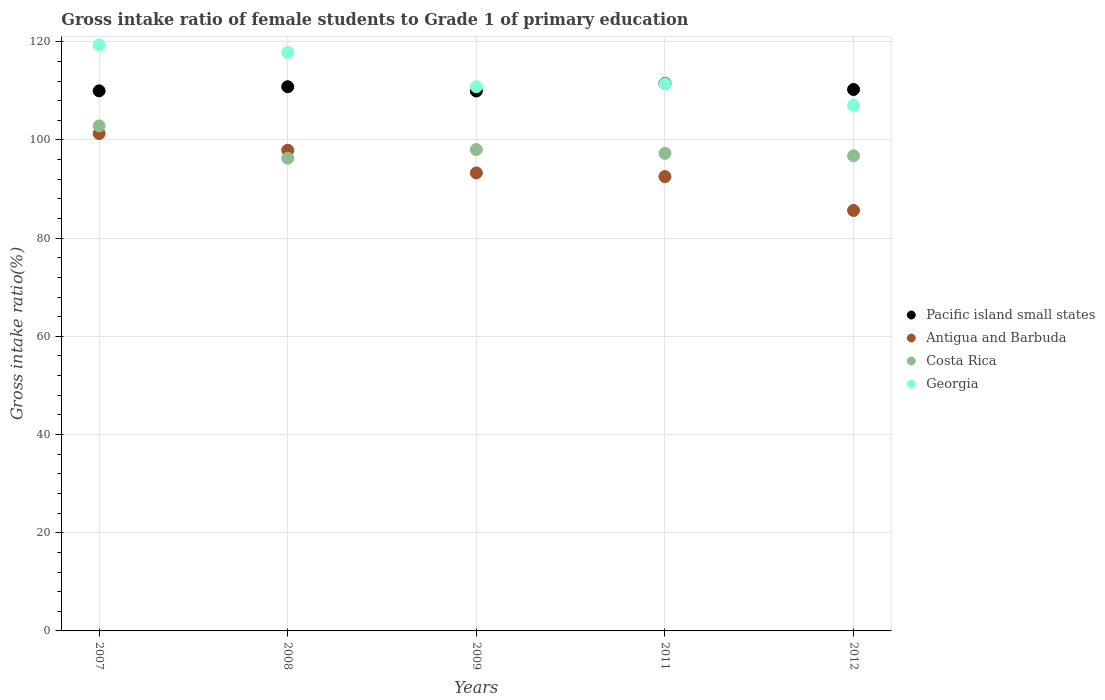How many different coloured dotlines are there?
Offer a terse response. 4. What is the gross intake ratio in Pacific island small states in 2007?
Keep it short and to the point. 110. Across all years, what is the maximum gross intake ratio in Costa Rica?
Ensure brevity in your answer.  102.86. Across all years, what is the minimum gross intake ratio in Georgia?
Provide a succinct answer. 107.07. In which year was the gross intake ratio in Antigua and Barbuda maximum?
Your response must be concise. 2007. In which year was the gross intake ratio in Antigua and Barbuda minimum?
Provide a succinct answer. 2012. What is the total gross intake ratio in Costa Rica in the graph?
Provide a short and direct response. 491.23. What is the difference between the gross intake ratio in Pacific island small states in 2009 and that in 2011?
Make the answer very short. -1.52. What is the difference between the gross intake ratio in Costa Rica in 2011 and the gross intake ratio in Pacific island small states in 2012?
Offer a terse response. -13.01. What is the average gross intake ratio in Costa Rica per year?
Keep it short and to the point. 98.25. In the year 2009, what is the difference between the gross intake ratio in Pacific island small states and gross intake ratio in Antigua and Barbuda?
Ensure brevity in your answer.  16.69. In how many years, is the gross intake ratio in Pacific island small states greater than 60 %?
Give a very brief answer. 5. What is the ratio of the gross intake ratio in Antigua and Barbuda in 2007 to that in 2011?
Make the answer very short. 1.09. What is the difference between the highest and the second highest gross intake ratio in Costa Rica?
Ensure brevity in your answer.  4.82. What is the difference between the highest and the lowest gross intake ratio in Antigua and Barbuda?
Your answer should be very brief. 15.67. Is the sum of the gross intake ratio in Pacific island small states in 2007 and 2011 greater than the maximum gross intake ratio in Antigua and Barbuda across all years?
Offer a very short reply. Yes. Is it the case that in every year, the sum of the gross intake ratio in Pacific island small states and gross intake ratio in Antigua and Barbuda  is greater than the gross intake ratio in Costa Rica?
Make the answer very short. Yes. Does the gross intake ratio in Georgia monotonically increase over the years?
Provide a short and direct response. No. Is the gross intake ratio in Georgia strictly less than the gross intake ratio in Antigua and Barbuda over the years?
Your response must be concise. No. How many years are there in the graph?
Your answer should be very brief. 5. What is the difference between two consecutive major ticks on the Y-axis?
Provide a short and direct response. 20. How are the legend labels stacked?
Offer a very short reply. Vertical. What is the title of the graph?
Offer a very short reply. Gross intake ratio of female students to Grade 1 of primary education. Does "Latin America(developing only)" appear as one of the legend labels in the graph?
Your response must be concise. No. What is the label or title of the Y-axis?
Keep it short and to the point. Gross intake ratio(%). What is the Gross intake ratio(%) in Pacific island small states in 2007?
Keep it short and to the point. 110. What is the Gross intake ratio(%) in Antigua and Barbuda in 2007?
Your answer should be compact. 101.31. What is the Gross intake ratio(%) of Costa Rica in 2007?
Offer a terse response. 102.86. What is the Gross intake ratio(%) of Georgia in 2007?
Your answer should be very brief. 119.37. What is the Gross intake ratio(%) in Pacific island small states in 2008?
Keep it short and to the point. 110.84. What is the Gross intake ratio(%) of Antigua and Barbuda in 2008?
Offer a very short reply. 97.9. What is the Gross intake ratio(%) of Costa Rica in 2008?
Your answer should be very brief. 96.28. What is the Gross intake ratio(%) of Georgia in 2008?
Keep it short and to the point. 117.82. What is the Gross intake ratio(%) of Pacific island small states in 2009?
Make the answer very short. 109.97. What is the Gross intake ratio(%) in Antigua and Barbuda in 2009?
Provide a short and direct response. 93.29. What is the Gross intake ratio(%) of Costa Rica in 2009?
Offer a terse response. 98.05. What is the Gross intake ratio(%) of Georgia in 2009?
Provide a succinct answer. 110.85. What is the Gross intake ratio(%) of Pacific island small states in 2011?
Your answer should be very brief. 111.49. What is the Gross intake ratio(%) in Antigua and Barbuda in 2011?
Your answer should be very brief. 92.54. What is the Gross intake ratio(%) of Costa Rica in 2011?
Offer a terse response. 97.27. What is the Gross intake ratio(%) in Georgia in 2011?
Give a very brief answer. 111.44. What is the Gross intake ratio(%) in Pacific island small states in 2012?
Your response must be concise. 110.28. What is the Gross intake ratio(%) of Antigua and Barbuda in 2012?
Your response must be concise. 85.64. What is the Gross intake ratio(%) of Costa Rica in 2012?
Give a very brief answer. 96.78. What is the Gross intake ratio(%) of Georgia in 2012?
Offer a very short reply. 107.07. Across all years, what is the maximum Gross intake ratio(%) of Pacific island small states?
Your answer should be very brief. 111.49. Across all years, what is the maximum Gross intake ratio(%) in Antigua and Barbuda?
Your answer should be compact. 101.31. Across all years, what is the maximum Gross intake ratio(%) in Costa Rica?
Ensure brevity in your answer.  102.86. Across all years, what is the maximum Gross intake ratio(%) of Georgia?
Your response must be concise. 119.37. Across all years, what is the minimum Gross intake ratio(%) in Pacific island small states?
Provide a short and direct response. 109.97. Across all years, what is the minimum Gross intake ratio(%) of Antigua and Barbuda?
Provide a short and direct response. 85.64. Across all years, what is the minimum Gross intake ratio(%) in Costa Rica?
Offer a terse response. 96.28. Across all years, what is the minimum Gross intake ratio(%) in Georgia?
Your response must be concise. 107.07. What is the total Gross intake ratio(%) in Pacific island small states in the graph?
Your answer should be compact. 552.59. What is the total Gross intake ratio(%) in Antigua and Barbuda in the graph?
Ensure brevity in your answer.  470.68. What is the total Gross intake ratio(%) of Costa Rica in the graph?
Offer a terse response. 491.23. What is the total Gross intake ratio(%) of Georgia in the graph?
Offer a terse response. 566.55. What is the difference between the Gross intake ratio(%) of Pacific island small states in 2007 and that in 2008?
Your answer should be compact. -0.84. What is the difference between the Gross intake ratio(%) in Antigua and Barbuda in 2007 and that in 2008?
Your answer should be compact. 3.41. What is the difference between the Gross intake ratio(%) of Costa Rica in 2007 and that in 2008?
Provide a succinct answer. 6.58. What is the difference between the Gross intake ratio(%) of Georgia in 2007 and that in 2008?
Provide a succinct answer. 1.55. What is the difference between the Gross intake ratio(%) of Pacific island small states in 2007 and that in 2009?
Ensure brevity in your answer.  0.02. What is the difference between the Gross intake ratio(%) in Antigua and Barbuda in 2007 and that in 2009?
Offer a terse response. 8.02. What is the difference between the Gross intake ratio(%) in Costa Rica in 2007 and that in 2009?
Your answer should be very brief. 4.82. What is the difference between the Gross intake ratio(%) of Georgia in 2007 and that in 2009?
Make the answer very short. 8.52. What is the difference between the Gross intake ratio(%) of Pacific island small states in 2007 and that in 2011?
Offer a terse response. -1.49. What is the difference between the Gross intake ratio(%) in Antigua and Barbuda in 2007 and that in 2011?
Offer a terse response. 8.77. What is the difference between the Gross intake ratio(%) in Costa Rica in 2007 and that in 2011?
Your response must be concise. 5.59. What is the difference between the Gross intake ratio(%) in Georgia in 2007 and that in 2011?
Offer a terse response. 7.93. What is the difference between the Gross intake ratio(%) in Pacific island small states in 2007 and that in 2012?
Make the answer very short. -0.28. What is the difference between the Gross intake ratio(%) in Antigua and Barbuda in 2007 and that in 2012?
Provide a short and direct response. 15.67. What is the difference between the Gross intake ratio(%) in Costa Rica in 2007 and that in 2012?
Keep it short and to the point. 6.08. What is the difference between the Gross intake ratio(%) in Georgia in 2007 and that in 2012?
Keep it short and to the point. 12.3. What is the difference between the Gross intake ratio(%) of Pacific island small states in 2008 and that in 2009?
Your response must be concise. 0.87. What is the difference between the Gross intake ratio(%) in Antigua and Barbuda in 2008 and that in 2009?
Your answer should be compact. 4.61. What is the difference between the Gross intake ratio(%) in Costa Rica in 2008 and that in 2009?
Provide a short and direct response. -1.77. What is the difference between the Gross intake ratio(%) in Georgia in 2008 and that in 2009?
Give a very brief answer. 6.97. What is the difference between the Gross intake ratio(%) in Pacific island small states in 2008 and that in 2011?
Make the answer very short. -0.65. What is the difference between the Gross intake ratio(%) in Antigua and Barbuda in 2008 and that in 2011?
Your response must be concise. 5.35. What is the difference between the Gross intake ratio(%) in Costa Rica in 2008 and that in 2011?
Ensure brevity in your answer.  -0.99. What is the difference between the Gross intake ratio(%) in Georgia in 2008 and that in 2011?
Your answer should be very brief. 6.38. What is the difference between the Gross intake ratio(%) of Pacific island small states in 2008 and that in 2012?
Your answer should be very brief. 0.56. What is the difference between the Gross intake ratio(%) in Antigua and Barbuda in 2008 and that in 2012?
Your response must be concise. 12.26. What is the difference between the Gross intake ratio(%) in Costa Rica in 2008 and that in 2012?
Give a very brief answer. -0.5. What is the difference between the Gross intake ratio(%) in Georgia in 2008 and that in 2012?
Ensure brevity in your answer.  10.75. What is the difference between the Gross intake ratio(%) in Pacific island small states in 2009 and that in 2011?
Keep it short and to the point. -1.52. What is the difference between the Gross intake ratio(%) in Antigua and Barbuda in 2009 and that in 2011?
Offer a terse response. 0.75. What is the difference between the Gross intake ratio(%) in Costa Rica in 2009 and that in 2011?
Offer a very short reply. 0.78. What is the difference between the Gross intake ratio(%) in Georgia in 2009 and that in 2011?
Provide a succinct answer. -0.59. What is the difference between the Gross intake ratio(%) of Pacific island small states in 2009 and that in 2012?
Offer a very short reply. -0.31. What is the difference between the Gross intake ratio(%) of Antigua and Barbuda in 2009 and that in 2012?
Offer a very short reply. 7.65. What is the difference between the Gross intake ratio(%) in Costa Rica in 2009 and that in 2012?
Keep it short and to the point. 1.27. What is the difference between the Gross intake ratio(%) in Georgia in 2009 and that in 2012?
Give a very brief answer. 3.78. What is the difference between the Gross intake ratio(%) of Pacific island small states in 2011 and that in 2012?
Give a very brief answer. 1.21. What is the difference between the Gross intake ratio(%) in Antigua and Barbuda in 2011 and that in 2012?
Your answer should be compact. 6.91. What is the difference between the Gross intake ratio(%) in Costa Rica in 2011 and that in 2012?
Offer a terse response. 0.49. What is the difference between the Gross intake ratio(%) in Georgia in 2011 and that in 2012?
Make the answer very short. 4.37. What is the difference between the Gross intake ratio(%) of Pacific island small states in 2007 and the Gross intake ratio(%) of Antigua and Barbuda in 2008?
Your answer should be compact. 12.1. What is the difference between the Gross intake ratio(%) in Pacific island small states in 2007 and the Gross intake ratio(%) in Costa Rica in 2008?
Offer a very short reply. 13.72. What is the difference between the Gross intake ratio(%) of Pacific island small states in 2007 and the Gross intake ratio(%) of Georgia in 2008?
Give a very brief answer. -7.82. What is the difference between the Gross intake ratio(%) in Antigua and Barbuda in 2007 and the Gross intake ratio(%) in Costa Rica in 2008?
Your answer should be compact. 5.03. What is the difference between the Gross intake ratio(%) of Antigua and Barbuda in 2007 and the Gross intake ratio(%) of Georgia in 2008?
Your answer should be very brief. -16.51. What is the difference between the Gross intake ratio(%) in Costa Rica in 2007 and the Gross intake ratio(%) in Georgia in 2008?
Provide a short and direct response. -14.96. What is the difference between the Gross intake ratio(%) in Pacific island small states in 2007 and the Gross intake ratio(%) in Antigua and Barbuda in 2009?
Offer a very short reply. 16.71. What is the difference between the Gross intake ratio(%) of Pacific island small states in 2007 and the Gross intake ratio(%) of Costa Rica in 2009?
Offer a terse response. 11.95. What is the difference between the Gross intake ratio(%) of Pacific island small states in 2007 and the Gross intake ratio(%) of Georgia in 2009?
Give a very brief answer. -0.85. What is the difference between the Gross intake ratio(%) in Antigua and Barbuda in 2007 and the Gross intake ratio(%) in Costa Rica in 2009?
Your response must be concise. 3.27. What is the difference between the Gross intake ratio(%) of Antigua and Barbuda in 2007 and the Gross intake ratio(%) of Georgia in 2009?
Your answer should be very brief. -9.54. What is the difference between the Gross intake ratio(%) in Costa Rica in 2007 and the Gross intake ratio(%) in Georgia in 2009?
Provide a short and direct response. -7.99. What is the difference between the Gross intake ratio(%) in Pacific island small states in 2007 and the Gross intake ratio(%) in Antigua and Barbuda in 2011?
Your response must be concise. 17.45. What is the difference between the Gross intake ratio(%) of Pacific island small states in 2007 and the Gross intake ratio(%) of Costa Rica in 2011?
Provide a succinct answer. 12.73. What is the difference between the Gross intake ratio(%) of Pacific island small states in 2007 and the Gross intake ratio(%) of Georgia in 2011?
Ensure brevity in your answer.  -1.45. What is the difference between the Gross intake ratio(%) of Antigua and Barbuda in 2007 and the Gross intake ratio(%) of Costa Rica in 2011?
Provide a succinct answer. 4.04. What is the difference between the Gross intake ratio(%) in Antigua and Barbuda in 2007 and the Gross intake ratio(%) in Georgia in 2011?
Keep it short and to the point. -10.13. What is the difference between the Gross intake ratio(%) of Costa Rica in 2007 and the Gross intake ratio(%) of Georgia in 2011?
Provide a short and direct response. -8.58. What is the difference between the Gross intake ratio(%) in Pacific island small states in 2007 and the Gross intake ratio(%) in Antigua and Barbuda in 2012?
Provide a short and direct response. 24.36. What is the difference between the Gross intake ratio(%) of Pacific island small states in 2007 and the Gross intake ratio(%) of Costa Rica in 2012?
Provide a short and direct response. 13.22. What is the difference between the Gross intake ratio(%) of Pacific island small states in 2007 and the Gross intake ratio(%) of Georgia in 2012?
Keep it short and to the point. 2.93. What is the difference between the Gross intake ratio(%) in Antigua and Barbuda in 2007 and the Gross intake ratio(%) in Costa Rica in 2012?
Give a very brief answer. 4.53. What is the difference between the Gross intake ratio(%) in Antigua and Barbuda in 2007 and the Gross intake ratio(%) in Georgia in 2012?
Your answer should be compact. -5.76. What is the difference between the Gross intake ratio(%) in Costa Rica in 2007 and the Gross intake ratio(%) in Georgia in 2012?
Your response must be concise. -4.21. What is the difference between the Gross intake ratio(%) of Pacific island small states in 2008 and the Gross intake ratio(%) of Antigua and Barbuda in 2009?
Your response must be concise. 17.55. What is the difference between the Gross intake ratio(%) in Pacific island small states in 2008 and the Gross intake ratio(%) in Costa Rica in 2009?
Make the answer very short. 12.8. What is the difference between the Gross intake ratio(%) in Pacific island small states in 2008 and the Gross intake ratio(%) in Georgia in 2009?
Your response must be concise. -0.01. What is the difference between the Gross intake ratio(%) in Antigua and Barbuda in 2008 and the Gross intake ratio(%) in Costa Rica in 2009?
Offer a terse response. -0.15. What is the difference between the Gross intake ratio(%) in Antigua and Barbuda in 2008 and the Gross intake ratio(%) in Georgia in 2009?
Give a very brief answer. -12.95. What is the difference between the Gross intake ratio(%) in Costa Rica in 2008 and the Gross intake ratio(%) in Georgia in 2009?
Give a very brief answer. -14.57. What is the difference between the Gross intake ratio(%) in Pacific island small states in 2008 and the Gross intake ratio(%) in Antigua and Barbuda in 2011?
Your answer should be compact. 18.3. What is the difference between the Gross intake ratio(%) in Pacific island small states in 2008 and the Gross intake ratio(%) in Costa Rica in 2011?
Provide a succinct answer. 13.58. What is the difference between the Gross intake ratio(%) in Pacific island small states in 2008 and the Gross intake ratio(%) in Georgia in 2011?
Your answer should be compact. -0.6. What is the difference between the Gross intake ratio(%) of Antigua and Barbuda in 2008 and the Gross intake ratio(%) of Costa Rica in 2011?
Give a very brief answer. 0.63. What is the difference between the Gross intake ratio(%) in Antigua and Barbuda in 2008 and the Gross intake ratio(%) in Georgia in 2011?
Provide a succinct answer. -13.55. What is the difference between the Gross intake ratio(%) of Costa Rica in 2008 and the Gross intake ratio(%) of Georgia in 2011?
Ensure brevity in your answer.  -15.17. What is the difference between the Gross intake ratio(%) in Pacific island small states in 2008 and the Gross intake ratio(%) in Antigua and Barbuda in 2012?
Your answer should be very brief. 25.2. What is the difference between the Gross intake ratio(%) of Pacific island small states in 2008 and the Gross intake ratio(%) of Costa Rica in 2012?
Give a very brief answer. 14.06. What is the difference between the Gross intake ratio(%) of Pacific island small states in 2008 and the Gross intake ratio(%) of Georgia in 2012?
Make the answer very short. 3.77. What is the difference between the Gross intake ratio(%) of Antigua and Barbuda in 2008 and the Gross intake ratio(%) of Costa Rica in 2012?
Offer a terse response. 1.12. What is the difference between the Gross intake ratio(%) of Antigua and Barbuda in 2008 and the Gross intake ratio(%) of Georgia in 2012?
Provide a short and direct response. -9.17. What is the difference between the Gross intake ratio(%) in Costa Rica in 2008 and the Gross intake ratio(%) in Georgia in 2012?
Provide a succinct answer. -10.79. What is the difference between the Gross intake ratio(%) of Pacific island small states in 2009 and the Gross intake ratio(%) of Antigua and Barbuda in 2011?
Your answer should be compact. 17.43. What is the difference between the Gross intake ratio(%) of Pacific island small states in 2009 and the Gross intake ratio(%) of Costa Rica in 2011?
Your answer should be very brief. 12.71. What is the difference between the Gross intake ratio(%) in Pacific island small states in 2009 and the Gross intake ratio(%) in Georgia in 2011?
Your answer should be compact. -1.47. What is the difference between the Gross intake ratio(%) in Antigua and Barbuda in 2009 and the Gross intake ratio(%) in Costa Rica in 2011?
Offer a terse response. -3.98. What is the difference between the Gross intake ratio(%) in Antigua and Barbuda in 2009 and the Gross intake ratio(%) in Georgia in 2011?
Your answer should be compact. -18.15. What is the difference between the Gross intake ratio(%) in Costa Rica in 2009 and the Gross intake ratio(%) in Georgia in 2011?
Offer a terse response. -13.4. What is the difference between the Gross intake ratio(%) in Pacific island small states in 2009 and the Gross intake ratio(%) in Antigua and Barbuda in 2012?
Make the answer very short. 24.34. What is the difference between the Gross intake ratio(%) in Pacific island small states in 2009 and the Gross intake ratio(%) in Costa Rica in 2012?
Your response must be concise. 13.2. What is the difference between the Gross intake ratio(%) in Pacific island small states in 2009 and the Gross intake ratio(%) in Georgia in 2012?
Ensure brevity in your answer.  2.9. What is the difference between the Gross intake ratio(%) of Antigua and Barbuda in 2009 and the Gross intake ratio(%) of Costa Rica in 2012?
Offer a terse response. -3.49. What is the difference between the Gross intake ratio(%) in Antigua and Barbuda in 2009 and the Gross intake ratio(%) in Georgia in 2012?
Your answer should be compact. -13.78. What is the difference between the Gross intake ratio(%) of Costa Rica in 2009 and the Gross intake ratio(%) of Georgia in 2012?
Ensure brevity in your answer.  -9.02. What is the difference between the Gross intake ratio(%) in Pacific island small states in 2011 and the Gross intake ratio(%) in Antigua and Barbuda in 2012?
Ensure brevity in your answer.  25.85. What is the difference between the Gross intake ratio(%) in Pacific island small states in 2011 and the Gross intake ratio(%) in Costa Rica in 2012?
Ensure brevity in your answer.  14.71. What is the difference between the Gross intake ratio(%) in Pacific island small states in 2011 and the Gross intake ratio(%) in Georgia in 2012?
Provide a succinct answer. 4.42. What is the difference between the Gross intake ratio(%) of Antigua and Barbuda in 2011 and the Gross intake ratio(%) of Costa Rica in 2012?
Make the answer very short. -4.23. What is the difference between the Gross intake ratio(%) of Antigua and Barbuda in 2011 and the Gross intake ratio(%) of Georgia in 2012?
Ensure brevity in your answer.  -14.53. What is the difference between the Gross intake ratio(%) in Costa Rica in 2011 and the Gross intake ratio(%) in Georgia in 2012?
Your response must be concise. -9.8. What is the average Gross intake ratio(%) of Pacific island small states per year?
Provide a succinct answer. 110.52. What is the average Gross intake ratio(%) of Antigua and Barbuda per year?
Provide a short and direct response. 94.14. What is the average Gross intake ratio(%) of Costa Rica per year?
Your answer should be compact. 98.25. What is the average Gross intake ratio(%) in Georgia per year?
Provide a succinct answer. 113.31. In the year 2007, what is the difference between the Gross intake ratio(%) in Pacific island small states and Gross intake ratio(%) in Antigua and Barbuda?
Your answer should be very brief. 8.69. In the year 2007, what is the difference between the Gross intake ratio(%) of Pacific island small states and Gross intake ratio(%) of Costa Rica?
Ensure brevity in your answer.  7.14. In the year 2007, what is the difference between the Gross intake ratio(%) in Pacific island small states and Gross intake ratio(%) in Georgia?
Your response must be concise. -9.37. In the year 2007, what is the difference between the Gross intake ratio(%) in Antigua and Barbuda and Gross intake ratio(%) in Costa Rica?
Offer a very short reply. -1.55. In the year 2007, what is the difference between the Gross intake ratio(%) in Antigua and Barbuda and Gross intake ratio(%) in Georgia?
Keep it short and to the point. -18.06. In the year 2007, what is the difference between the Gross intake ratio(%) in Costa Rica and Gross intake ratio(%) in Georgia?
Keep it short and to the point. -16.51. In the year 2008, what is the difference between the Gross intake ratio(%) of Pacific island small states and Gross intake ratio(%) of Antigua and Barbuda?
Keep it short and to the point. 12.94. In the year 2008, what is the difference between the Gross intake ratio(%) in Pacific island small states and Gross intake ratio(%) in Costa Rica?
Provide a short and direct response. 14.56. In the year 2008, what is the difference between the Gross intake ratio(%) of Pacific island small states and Gross intake ratio(%) of Georgia?
Ensure brevity in your answer.  -6.98. In the year 2008, what is the difference between the Gross intake ratio(%) of Antigua and Barbuda and Gross intake ratio(%) of Costa Rica?
Your answer should be compact. 1.62. In the year 2008, what is the difference between the Gross intake ratio(%) in Antigua and Barbuda and Gross intake ratio(%) in Georgia?
Ensure brevity in your answer.  -19.92. In the year 2008, what is the difference between the Gross intake ratio(%) in Costa Rica and Gross intake ratio(%) in Georgia?
Give a very brief answer. -21.54. In the year 2009, what is the difference between the Gross intake ratio(%) of Pacific island small states and Gross intake ratio(%) of Antigua and Barbuda?
Your answer should be very brief. 16.69. In the year 2009, what is the difference between the Gross intake ratio(%) of Pacific island small states and Gross intake ratio(%) of Costa Rica?
Provide a succinct answer. 11.93. In the year 2009, what is the difference between the Gross intake ratio(%) in Pacific island small states and Gross intake ratio(%) in Georgia?
Keep it short and to the point. -0.87. In the year 2009, what is the difference between the Gross intake ratio(%) of Antigua and Barbuda and Gross intake ratio(%) of Costa Rica?
Provide a short and direct response. -4.76. In the year 2009, what is the difference between the Gross intake ratio(%) in Antigua and Barbuda and Gross intake ratio(%) in Georgia?
Your answer should be compact. -17.56. In the year 2009, what is the difference between the Gross intake ratio(%) in Costa Rica and Gross intake ratio(%) in Georgia?
Your response must be concise. -12.8. In the year 2011, what is the difference between the Gross intake ratio(%) of Pacific island small states and Gross intake ratio(%) of Antigua and Barbuda?
Offer a very short reply. 18.95. In the year 2011, what is the difference between the Gross intake ratio(%) in Pacific island small states and Gross intake ratio(%) in Costa Rica?
Give a very brief answer. 14.23. In the year 2011, what is the difference between the Gross intake ratio(%) in Pacific island small states and Gross intake ratio(%) in Georgia?
Your response must be concise. 0.05. In the year 2011, what is the difference between the Gross intake ratio(%) of Antigua and Barbuda and Gross intake ratio(%) of Costa Rica?
Your answer should be very brief. -4.72. In the year 2011, what is the difference between the Gross intake ratio(%) in Antigua and Barbuda and Gross intake ratio(%) in Georgia?
Give a very brief answer. -18.9. In the year 2011, what is the difference between the Gross intake ratio(%) of Costa Rica and Gross intake ratio(%) of Georgia?
Make the answer very short. -14.18. In the year 2012, what is the difference between the Gross intake ratio(%) of Pacific island small states and Gross intake ratio(%) of Antigua and Barbuda?
Your answer should be compact. 24.64. In the year 2012, what is the difference between the Gross intake ratio(%) of Pacific island small states and Gross intake ratio(%) of Costa Rica?
Offer a very short reply. 13.5. In the year 2012, what is the difference between the Gross intake ratio(%) of Pacific island small states and Gross intake ratio(%) of Georgia?
Make the answer very short. 3.21. In the year 2012, what is the difference between the Gross intake ratio(%) in Antigua and Barbuda and Gross intake ratio(%) in Costa Rica?
Offer a terse response. -11.14. In the year 2012, what is the difference between the Gross intake ratio(%) in Antigua and Barbuda and Gross intake ratio(%) in Georgia?
Provide a short and direct response. -21.43. In the year 2012, what is the difference between the Gross intake ratio(%) in Costa Rica and Gross intake ratio(%) in Georgia?
Your answer should be very brief. -10.29. What is the ratio of the Gross intake ratio(%) of Pacific island small states in 2007 to that in 2008?
Ensure brevity in your answer.  0.99. What is the ratio of the Gross intake ratio(%) in Antigua and Barbuda in 2007 to that in 2008?
Provide a short and direct response. 1.03. What is the ratio of the Gross intake ratio(%) in Costa Rica in 2007 to that in 2008?
Give a very brief answer. 1.07. What is the ratio of the Gross intake ratio(%) of Georgia in 2007 to that in 2008?
Provide a succinct answer. 1.01. What is the ratio of the Gross intake ratio(%) in Pacific island small states in 2007 to that in 2009?
Give a very brief answer. 1. What is the ratio of the Gross intake ratio(%) of Antigua and Barbuda in 2007 to that in 2009?
Provide a short and direct response. 1.09. What is the ratio of the Gross intake ratio(%) in Costa Rica in 2007 to that in 2009?
Your response must be concise. 1.05. What is the ratio of the Gross intake ratio(%) of Georgia in 2007 to that in 2009?
Make the answer very short. 1.08. What is the ratio of the Gross intake ratio(%) of Pacific island small states in 2007 to that in 2011?
Offer a terse response. 0.99. What is the ratio of the Gross intake ratio(%) in Antigua and Barbuda in 2007 to that in 2011?
Make the answer very short. 1.09. What is the ratio of the Gross intake ratio(%) of Costa Rica in 2007 to that in 2011?
Your answer should be compact. 1.06. What is the ratio of the Gross intake ratio(%) of Georgia in 2007 to that in 2011?
Your response must be concise. 1.07. What is the ratio of the Gross intake ratio(%) of Antigua and Barbuda in 2007 to that in 2012?
Make the answer very short. 1.18. What is the ratio of the Gross intake ratio(%) in Costa Rica in 2007 to that in 2012?
Your answer should be compact. 1.06. What is the ratio of the Gross intake ratio(%) in Georgia in 2007 to that in 2012?
Give a very brief answer. 1.11. What is the ratio of the Gross intake ratio(%) in Pacific island small states in 2008 to that in 2009?
Give a very brief answer. 1.01. What is the ratio of the Gross intake ratio(%) of Antigua and Barbuda in 2008 to that in 2009?
Ensure brevity in your answer.  1.05. What is the ratio of the Gross intake ratio(%) of Costa Rica in 2008 to that in 2009?
Provide a succinct answer. 0.98. What is the ratio of the Gross intake ratio(%) of Georgia in 2008 to that in 2009?
Your response must be concise. 1.06. What is the ratio of the Gross intake ratio(%) of Antigua and Barbuda in 2008 to that in 2011?
Your answer should be very brief. 1.06. What is the ratio of the Gross intake ratio(%) in Georgia in 2008 to that in 2011?
Give a very brief answer. 1.06. What is the ratio of the Gross intake ratio(%) of Antigua and Barbuda in 2008 to that in 2012?
Offer a very short reply. 1.14. What is the ratio of the Gross intake ratio(%) in Georgia in 2008 to that in 2012?
Provide a short and direct response. 1.1. What is the ratio of the Gross intake ratio(%) of Pacific island small states in 2009 to that in 2011?
Your response must be concise. 0.99. What is the ratio of the Gross intake ratio(%) of Costa Rica in 2009 to that in 2011?
Give a very brief answer. 1.01. What is the ratio of the Gross intake ratio(%) in Georgia in 2009 to that in 2011?
Provide a short and direct response. 0.99. What is the ratio of the Gross intake ratio(%) of Pacific island small states in 2009 to that in 2012?
Offer a terse response. 1. What is the ratio of the Gross intake ratio(%) of Antigua and Barbuda in 2009 to that in 2012?
Offer a very short reply. 1.09. What is the ratio of the Gross intake ratio(%) of Costa Rica in 2009 to that in 2012?
Make the answer very short. 1.01. What is the ratio of the Gross intake ratio(%) of Georgia in 2009 to that in 2012?
Give a very brief answer. 1.04. What is the ratio of the Gross intake ratio(%) of Antigua and Barbuda in 2011 to that in 2012?
Keep it short and to the point. 1.08. What is the ratio of the Gross intake ratio(%) of Georgia in 2011 to that in 2012?
Offer a very short reply. 1.04. What is the difference between the highest and the second highest Gross intake ratio(%) in Pacific island small states?
Your answer should be compact. 0.65. What is the difference between the highest and the second highest Gross intake ratio(%) of Antigua and Barbuda?
Offer a terse response. 3.41. What is the difference between the highest and the second highest Gross intake ratio(%) in Costa Rica?
Your answer should be compact. 4.82. What is the difference between the highest and the second highest Gross intake ratio(%) of Georgia?
Give a very brief answer. 1.55. What is the difference between the highest and the lowest Gross intake ratio(%) in Pacific island small states?
Ensure brevity in your answer.  1.52. What is the difference between the highest and the lowest Gross intake ratio(%) in Antigua and Barbuda?
Your answer should be very brief. 15.67. What is the difference between the highest and the lowest Gross intake ratio(%) in Costa Rica?
Give a very brief answer. 6.58. What is the difference between the highest and the lowest Gross intake ratio(%) in Georgia?
Your answer should be compact. 12.3. 